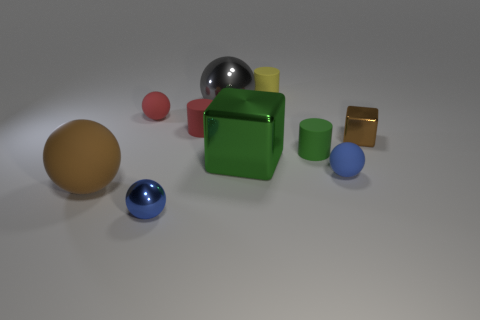There is a shiny thing that is the same color as the big rubber ball; what size is it?
Keep it short and to the point. Small. What is the material of the sphere that is behind the green shiny object and on the left side of the gray metallic object?
Keep it short and to the point. Rubber. What is the shape of the small green object that is made of the same material as the red cylinder?
Give a very brief answer. Cylinder. Are there any other things that are the same color as the large rubber thing?
Make the answer very short. Yes. Are there more red matte cylinders that are behind the tiny brown metal block than big blue objects?
Give a very brief answer. Yes. What material is the tiny cube?
Offer a very short reply. Metal. What number of brown rubber things have the same size as the green shiny object?
Give a very brief answer. 1. Is the number of big spheres behind the big green metallic block the same as the number of cubes that are right of the tiny green rubber thing?
Give a very brief answer. Yes. Is the gray object made of the same material as the big brown ball?
Keep it short and to the point. No. There is a tiny blue metal object in front of the tiny brown metal cube; are there any large objects to the left of it?
Offer a very short reply. Yes. 